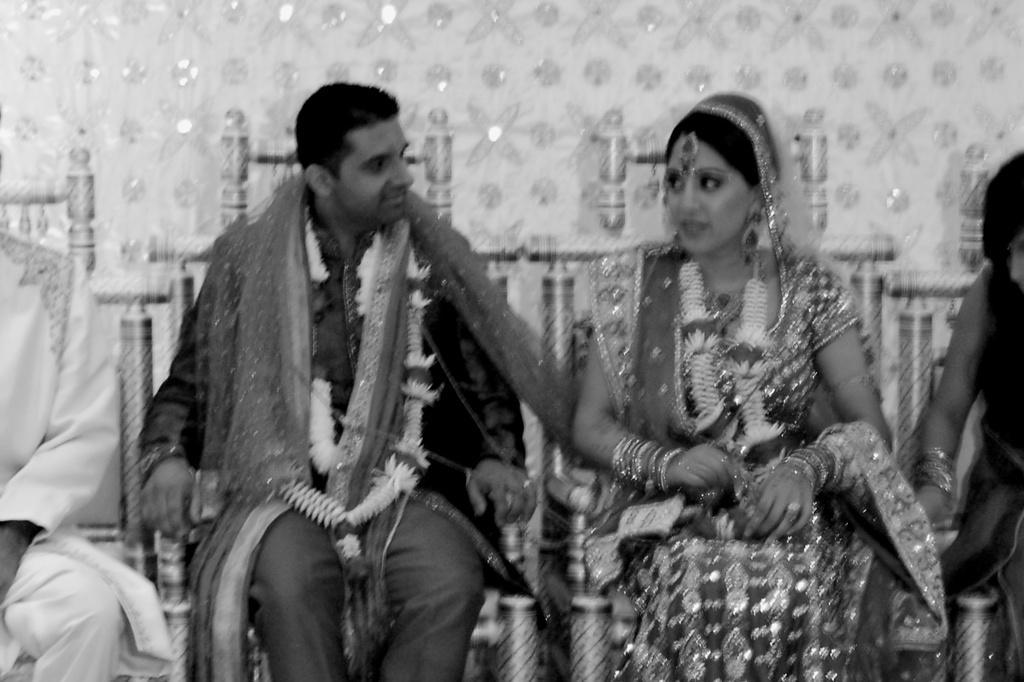Please provide a concise description of this image. This is a black and white image and here we can see a bride and a bridegroom in traditional wedding dress and wearing garlands and sitting on the chairs. In the background, we can see some other people and there is a wall. 